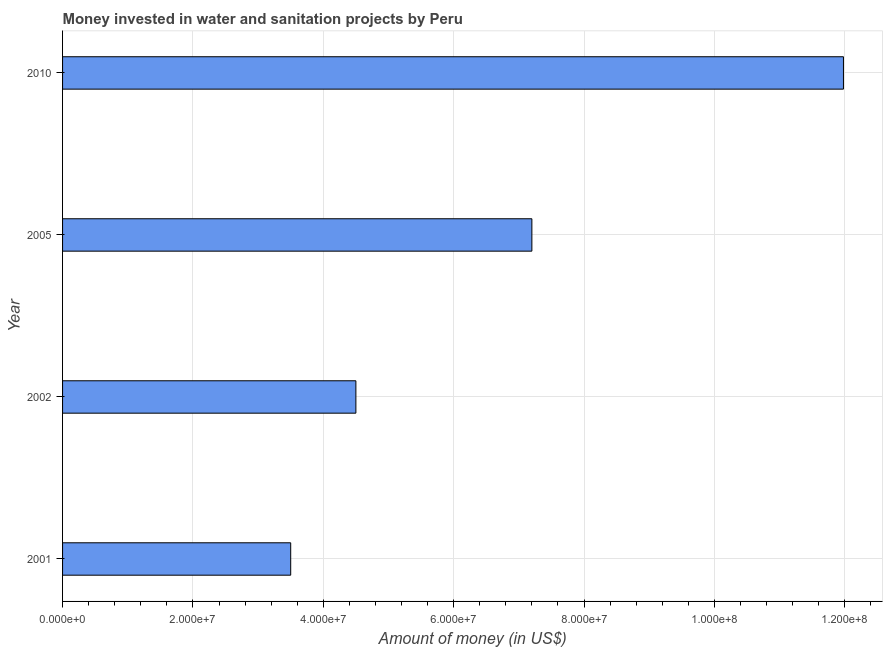Does the graph contain any zero values?
Your answer should be very brief. No. What is the title of the graph?
Your answer should be very brief. Money invested in water and sanitation projects by Peru. What is the label or title of the X-axis?
Offer a very short reply. Amount of money (in US$). What is the label or title of the Y-axis?
Your answer should be compact. Year. What is the investment in 2005?
Ensure brevity in your answer.  7.20e+07. Across all years, what is the maximum investment?
Offer a very short reply. 1.20e+08. Across all years, what is the minimum investment?
Offer a terse response. 3.50e+07. What is the sum of the investment?
Your response must be concise. 2.72e+08. What is the difference between the investment in 2002 and 2005?
Make the answer very short. -2.70e+07. What is the average investment per year?
Offer a terse response. 6.80e+07. What is the median investment?
Offer a very short reply. 5.85e+07. What is the ratio of the investment in 2001 to that in 2002?
Your answer should be very brief. 0.78. What is the difference between the highest and the second highest investment?
Give a very brief answer. 4.78e+07. What is the difference between the highest and the lowest investment?
Your answer should be very brief. 8.48e+07. Are all the bars in the graph horizontal?
Your answer should be compact. Yes. What is the difference between two consecutive major ticks on the X-axis?
Make the answer very short. 2.00e+07. What is the Amount of money (in US$) of 2001?
Make the answer very short. 3.50e+07. What is the Amount of money (in US$) in 2002?
Provide a short and direct response. 4.50e+07. What is the Amount of money (in US$) of 2005?
Offer a very short reply. 7.20e+07. What is the Amount of money (in US$) of 2010?
Keep it short and to the point. 1.20e+08. What is the difference between the Amount of money (in US$) in 2001 and 2002?
Your answer should be compact. -1.00e+07. What is the difference between the Amount of money (in US$) in 2001 and 2005?
Keep it short and to the point. -3.70e+07. What is the difference between the Amount of money (in US$) in 2001 and 2010?
Your answer should be very brief. -8.48e+07. What is the difference between the Amount of money (in US$) in 2002 and 2005?
Provide a short and direct response. -2.70e+07. What is the difference between the Amount of money (in US$) in 2002 and 2010?
Your answer should be very brief. -7.48e+07. What is the difference between the Amount of money (in US$) in 2005 and 2010?
Your answer should be compact. -4.78e+07. What is the ratio of the Amount of money (in US$) in 2001 to that in 2002?
Provide a succinct answer. 0.78. What is the ratio of the Amount of money (in US$) in 2001 to that in 2005?
Provide a short and direct response. 0.49. What is the ratio of the Amount of money (in US$) in 2001 to that in 2010?
Ensure brevity in your answer.  0.29. What is the ratio of the Amount of money (in US$) in 2002 to that in 2010?
Make the answer very short. 0.38. What is the ratio of the Amount of money (in US$) in 2005 to that in 2010?
Provide a short and direct response. 0.6. 